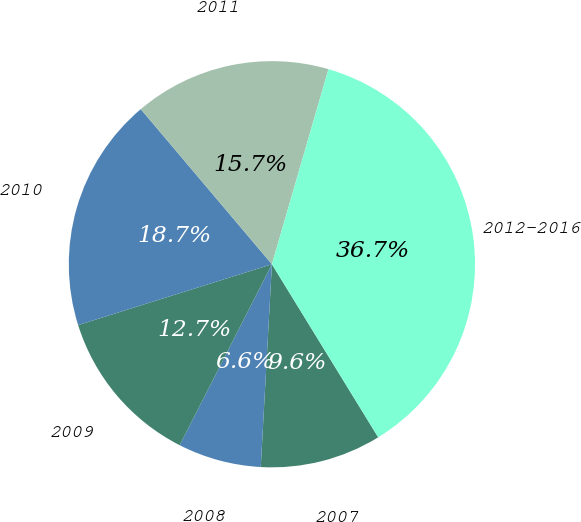Convert chart. <chart><loc_0><loc_0><loc_500><loc_500><pie_chart><fcel>2007<fcel>2008<fcel>2009<fcel>2010<fcel>2011<fcel>2012-2016<nl><fcel>9.64%<fcel>6.63%<fcel>12.65%<fcel>18.67%<fcel>15.66%<fcel>36.74%<nl></chart> 